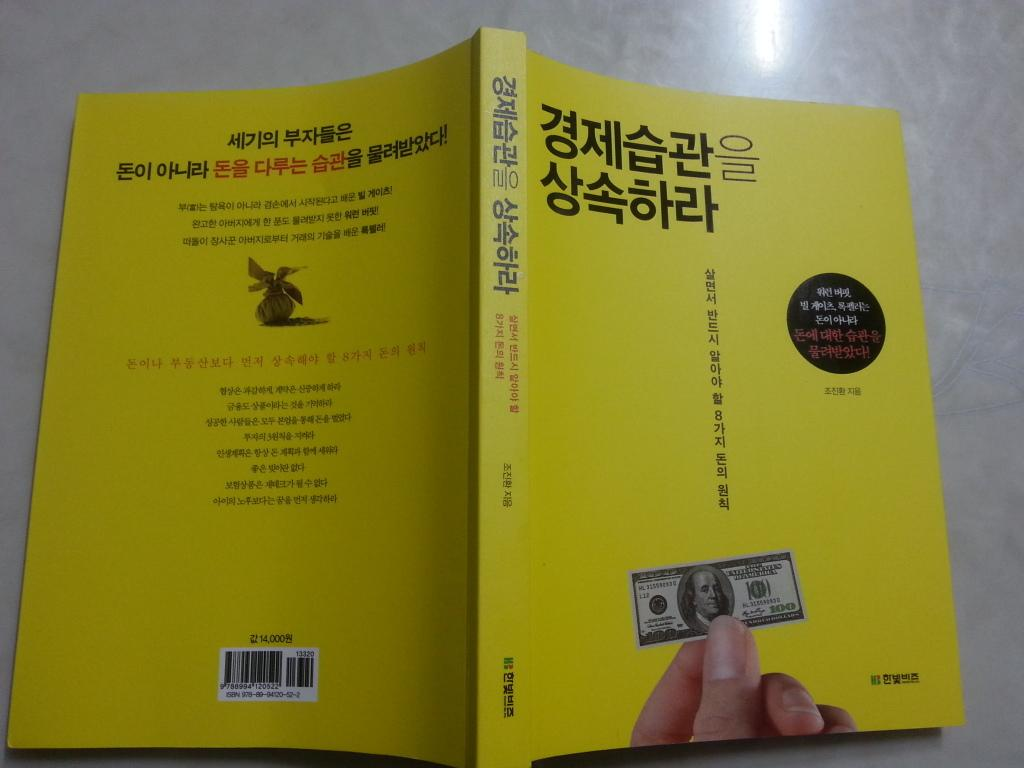<image>
Write a terse but informative summary of the picture. A yellow book has a picture of a one hundred dollar bill on it. 